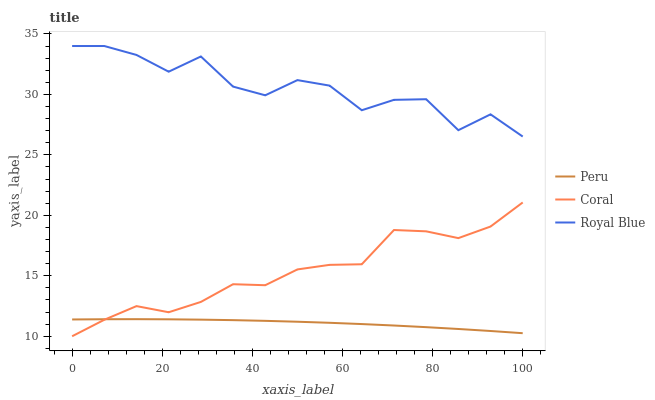Does Peru have the minimum area under the curve?
Answer yes or no. Yes. Does Royal Blue have the maximum area under the curve?
Answer yes or no. Yes. Does Coral have the minimum area under the curve?
Answer yes or no. No. Does Coral have the maximum area under the curve?
Answer yes or no. No. Is Peru the smoothest?
Answer yes or no. Yes. Is Royal Blue the roughest?
Answer yes or no. Yes. Is Coral the smoothest?
Answer yes or no. No. Is Coral the roughest?
Answer yes or no. No. Does Coral have the lowest value?
Answer yes or no. Yes. Does Peru have the lowest value?
Answer yes or no. No. Does Royal Blue have the highest value?
Answer yes or no. Yes. Does Coral have the highest value?
Answer yes or no. No. Is Coral less than Royal Blue?
Answer yes or no. Yes. Is Royal Blue greater than Peru?
Answer yes or no. Yes. Does Peru intersect Coral?
Answer yes or no. Yes. Is Peru less than Coral?
Answer yes or no. No. Is Peru greater than Coral?
Answer yes or no. No. Does Coral intersect Royal Blue?
Answer yes or no. No. 